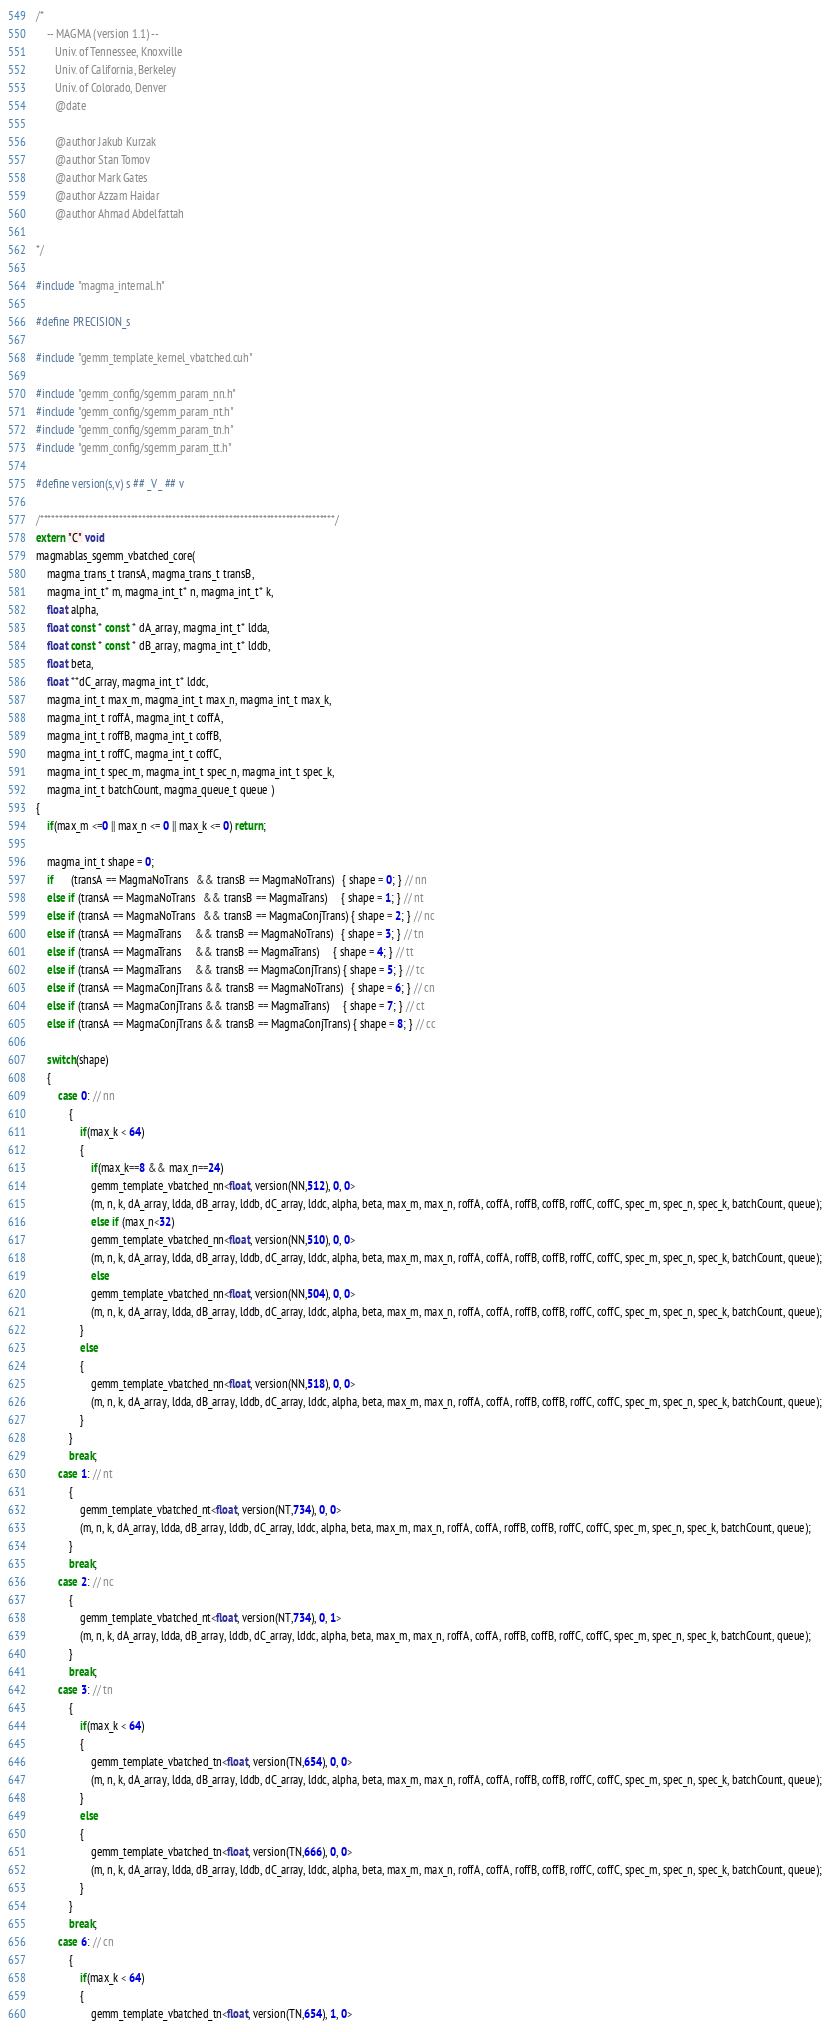<code> <loc_0><loc_0><loc_500><loc_500><_Cuda_>/*
    -- MAGMA (version 1.1) --
       Univ. of Tennessee, Knoxville
       Univ. of California, Berkeley
       Univ. of Colorado, Denver
       @date

       @author Jakub Kurzak
       @author Stan Tomov
       @author Mark Gates
       @author Azzam Haidar
       @author Ahmad Abdelfattah
       
*/

#include "magma_internal.h"

#define PRECISION_s

#include "gemm_template_kernel_vbatched.cuh"

#include "gemm_config/sgemm_param_nn.h"
#include "gemm_config/sgemm_param_nt.h"
#include "gemm_config/sgemm_param_tn.h"
#include "gemm_config/sgemm_param_tt.h"

#define version(s,v) s ## _V_ ## v

/******************************************************************************/
extern "C" void 
magmablas_sgemm_vbatched_core(
    magma_trans_t transA, magma_trans_t transB, 
    magma_int_t* m, magma_int_t* n, magma_int_t* k,
    float alpha,
    float const * const * dA_array, magma_int_t* ldda,
    float const * const * dB_array, magma_int_t* lddb,
    float beta,
    float **dC_array, magma_int_t* lddc, 
    magma_int_t max_m, magma_int_t max_n, magma_int_t max_k, 
    magma_int_t roffA, magma_int_t coffA,
    magma_int_t roffB, magma_int_t coffB,
    magma_int_t roffC, magma_int_t coffC, 
    magma_int_t spec_m, magma_int_t spec_n, magma_int_t spec_k, 
    magma_int_t batchCount, magma_queue_t queue )
{
    if(max_m <=0 || max_n <= 0 || max_k <= 0) return;
    
    magma_int_t shape = 0;
    if      (transA == MagmaNoTrans   && transB == MagmaNoTrans)   { shape = 0; } // nn
    else if (transA == MagmaNoTrans   && transB == MagmaTrans)     { shape = 1; } // nt
    else if (transA == MagmaNoTrans   && transB == MagmaConjTrans) { shape = 2; } // nc
    else if (transA == MagmaTrans     && transB == MagmaNoTrans)   { shape = 3; } // tn
    else if (transA == MagmaTrans     && transB == MagmaTrans)     { shape = 4; } // tt
    else if (transA == MagmaTrans     && transB == MagmaConjTrans) { shape = 5; } // tc
    else if (transA == MagmaConjTrans && transB == MagmaNoTrans)   { shape = 6; } // cn
    else if (transA == MagmaConjTrans && transB == MagmaTrans)     { shape = 7; } // ct
    else if (transA == MagmaConjTrans && transB == MagmaConjTrans) { shape = 8; } // cc
    
    switch(shape)
    {
        case 0: // nn
            {
                if(max_k < 64)
                {
                    if(max_k==8 && max_n==24)
                    gemm_template_vbatched_nn<float, version(NN,512), 0, 0>
                    (m, n, k, dA_array, ldda, dB_array, lddb, dC_array, lddc, alpha, beta, max_m, max_n, roffA, coffA, roffB, coffB, roffC, coffC, spec_m, spec_n, spec_k, batchCount, queue);
                    else if (max_n<32)
                    gemm_template_vbatched_nn<float, version(NN,510), 0, 0>
                    (m, n, k, dA_array, ldda, dB_array, lddb, dC_array, lddc, alpha, beta, max_m, max_n, roffA, coffA, roffB, coffB, roffC, coffC, spec_m, spec_n, spec_k, batchCount, queue);
                    else
                    gemm_template_vbatched_nn<float, version(NN,504), 0, 0>
                    (m, n, k, dA_array, ldda, dB_array, lddb, dC_array, lddc, alpha, beta, max_m, max_n, roffA, coffA, roffB, coffB, roffC, coffC, spec_m, spec_n, spec_k, batchCount, queue);
                }
                else
                {
                    gemm_template_vbatched_nn<float, version(NN,518), 0, 0>
                    (m, n, k, dA_array, ldda, dB_array, lddb, dC_array, lddc, alpha, beta, max_m, max_n, roffA, coffA, roffB, coffB, roffC, coffC, spec_m, spec_n, spec_k, batchCount, queue);
                }
            }
            break;
        case 1: // nt
            {
                gemm_template_vbatched_nt<float, version(NT,734), 0, 0>
                (m, n, k, dA_array, ldda, dB_array, lddb, dC_array, lddc, alpha, beta, max_m, max_n, roffA, coffA, roffB, coffB, roffC, coffC, spec_m, spec_n, spec_k, batchCount, queue);
            }
            break;
        case 2: // nc
            {
                gemm_template_vbatched_nt<float, version(NT,734), 0, 1>
                (m, n, k, dA_array, ldda, dB_array, lddb, dC_array, lddc, alpha, beta, max_m, max_n, roffA, coffA, roffB, coffB, roffC, coffC, spec_m, spec_n, spec_k, batchCount, queue);
            }
            break;
        case 3: // tn
            {
                if(max_k < 64)
                {
                    gemm_template_vbatched_tn<float, version(TN,654), 0, 0>
                    (m, n, k, dA_array, ldda, dB_array, lddb, dC_array, lddc, alpha, beta, max_m, max_n, roffA, coffA, roffB, coffB, roffC, coffC, spec_m, spec_n, spec_k, batchCount, queue);
                }
                else
                {
                    gemm_template_vbatched_tn<float, version(TN,666), 0, 0>
                    (m, n, k, dA_array, ldda, dB_array, lddb, dC_array, lddc, alpha, beta, max_m, max_n, roffA, coffA, roffB, coffB, roffC, coffC, spec_m, spec_n, spec_k, batchCount, queue);
                }
            }
            break;
        case 6: // cn
            {
                if(max_k < 64)
                {
                    gemm_template_vbatched_tn<float, version(TN,654), 1, 0></code> 